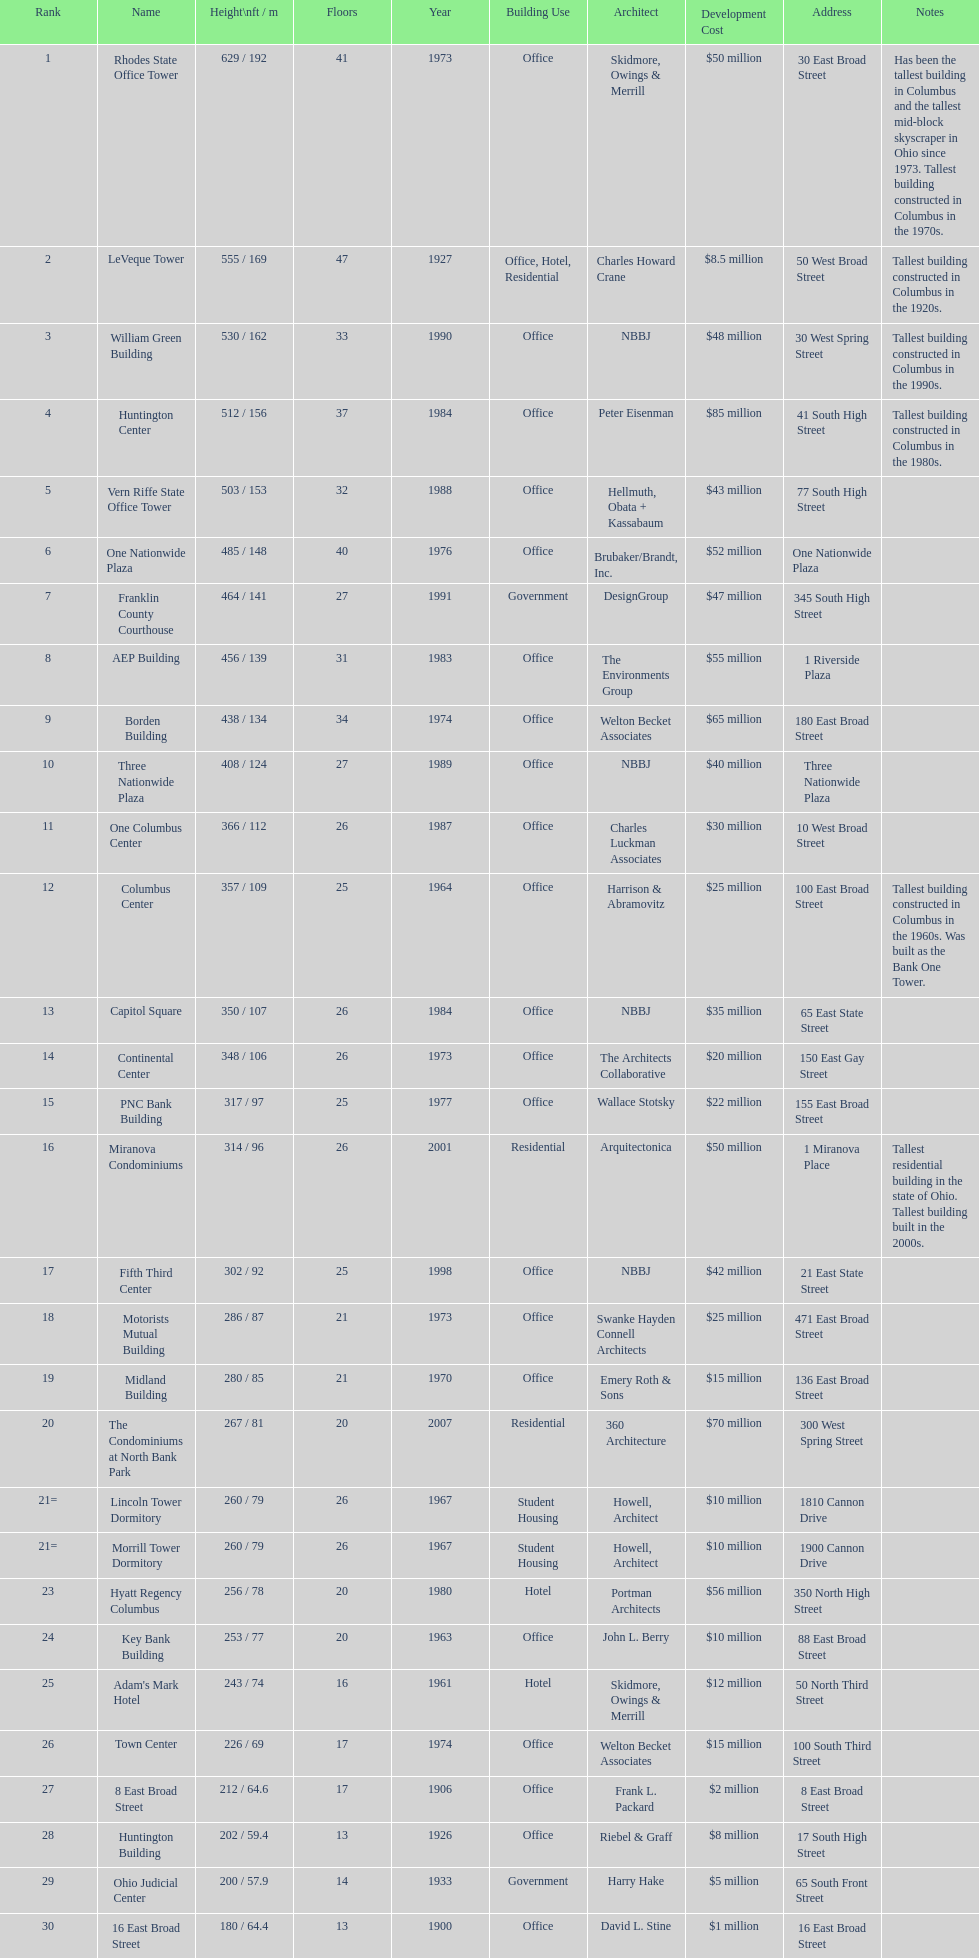What is the number of buildings under 200 ft? 1. 